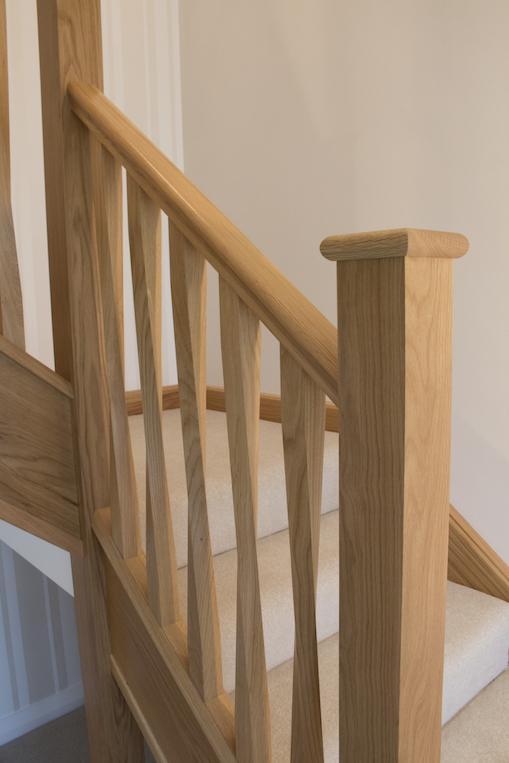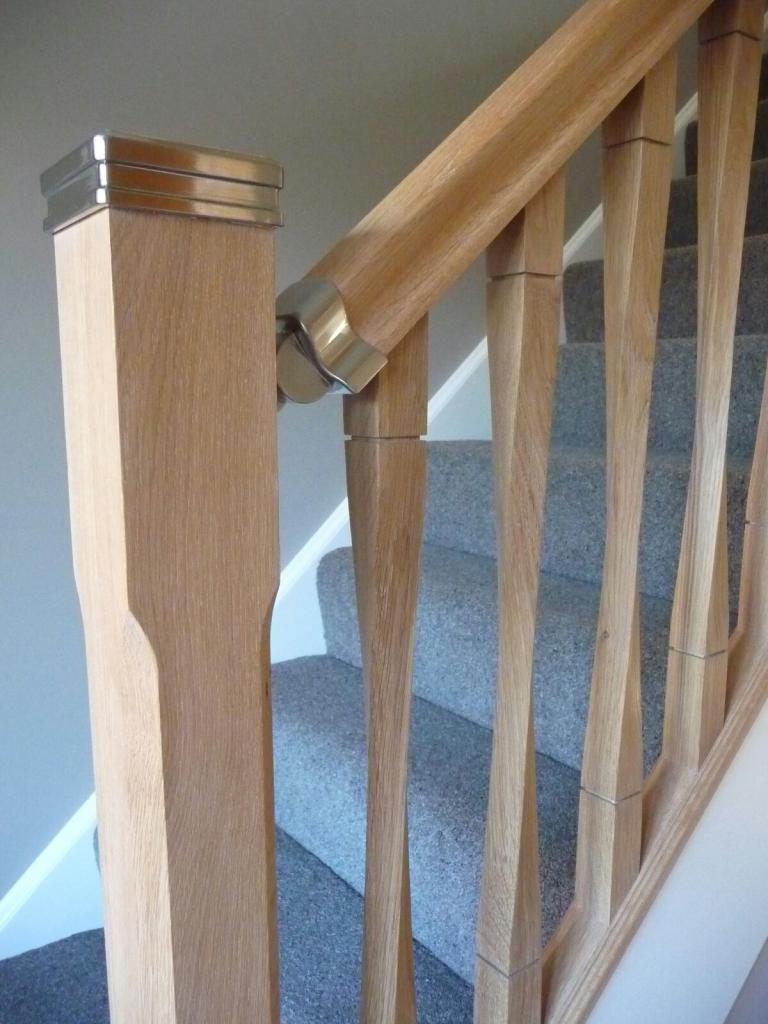The first image is the image on the left, the second image is the image on the right. Assess this claim about the two images: "In one of the images, the stairway post is made of wood and metal.". Correct or not? Answer yes or no. Yes. The first image is the image on the left, the second image is the image on the right. For the images displayed, is the sentence "One image shows a wooden stair baluster with a silver cap, and vertical rails of twisted wood in front of gray carpeting." factually correct? Answer yes or no. Yes. 